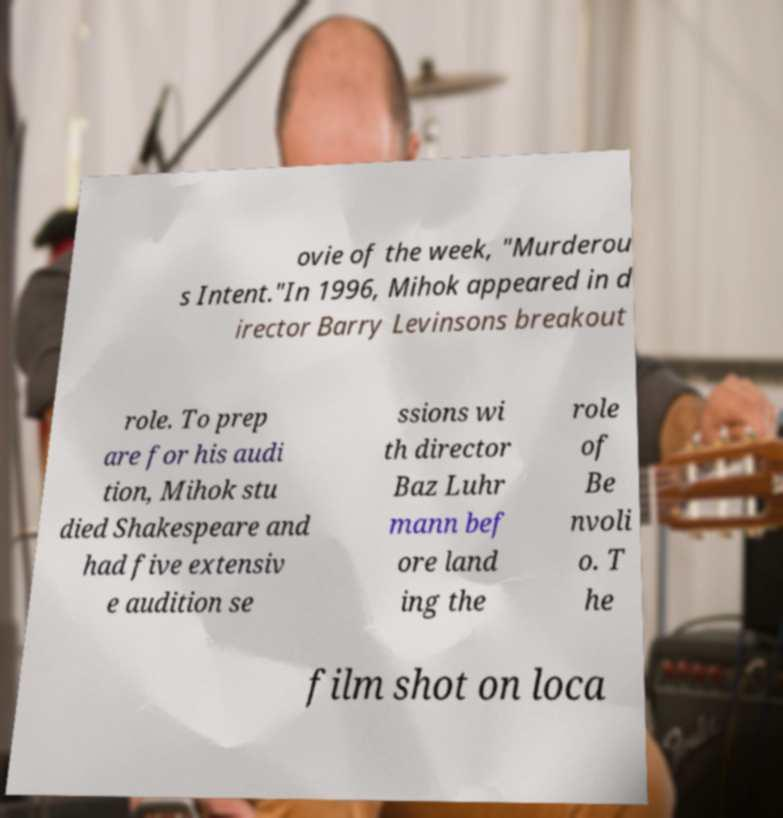For documentation purposes, I need the text within this image transcribed. Could you provide that? ovie of the week, "Murderou s Intent."In 1996, Mihok appeared in d irector Barry Levinsons breakout role. To prep are for his audi tion, Mihok stu died Shakespeare and had five extensiv e audition se ssions wi th director Baz Luhr mann bef ore land ing the role of Be nvoli o. T he film shot on loca 